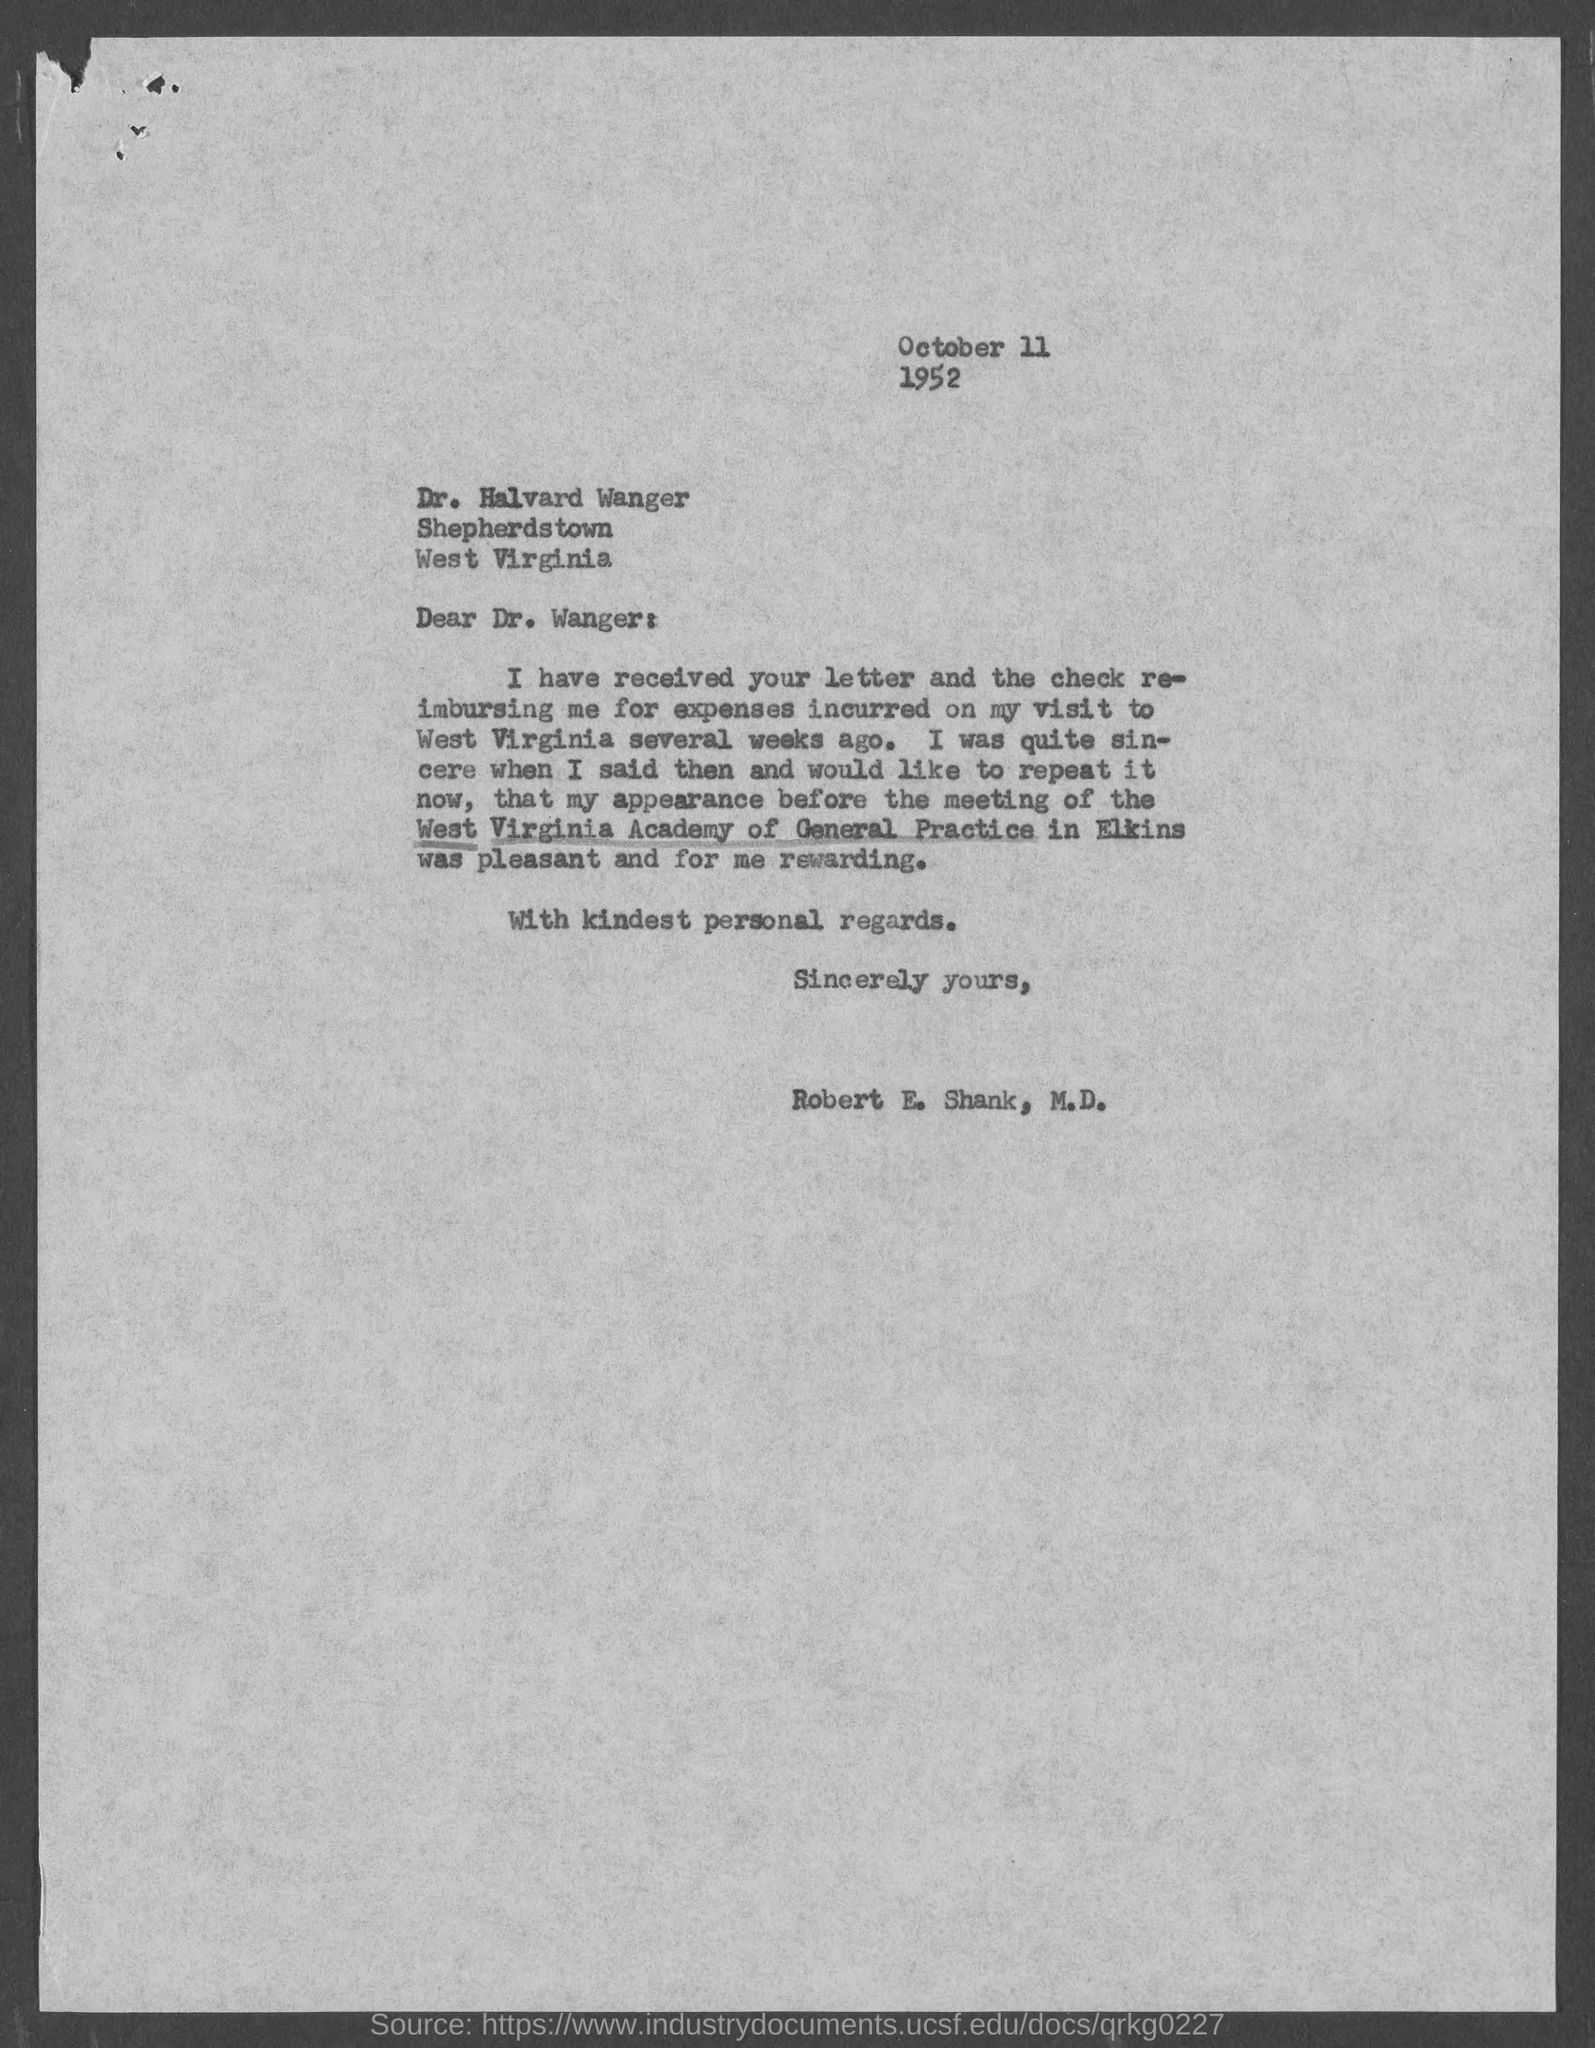Identify some key points in this picture. The meeting was held in Elkins. The letter is addressed to Dr. Halvard Wanger. 